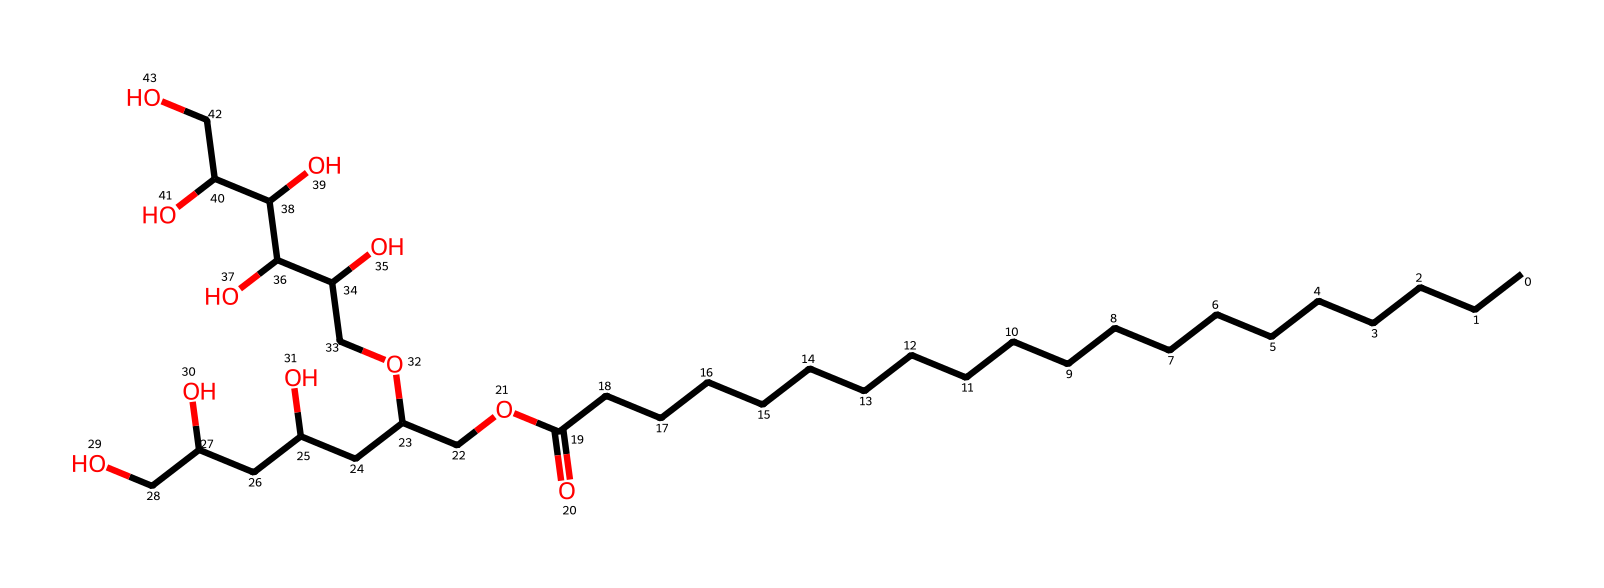What is the common name of this chemical? The SMILES string corresponds to Polysorbate 20, commonly known as Tween 20, which is a non-ionic surfactant.
Answer: Tween 20 How many carbon atoms are present in this molecule? By counting the 'C' characters in the SMILES representation, there are 20 carbon atoms in total.
Answer: 20 What type of functional group is indicated by "OCC" in this structure? The "OCC" part indicates an ether or ester functional group due to the presence of carbon (C) chains flanked by oxygen (O).
Answer: ether Is this molecule hydrophilic or hydrophobic? The presence of multiple hydroxyl (OH) groups indicates that it is hydrophilic, as these groups attract water molecules.
Answer: hydrophilic How many hydroxyl groups are present in the molecular structure? By identifying "O" that is immediately followed by hydrogen or carbon atoms, there are a total of 6 hydroxyl groups in the structure.
Answer: 6 What role does Polysorbate 20 serve in food products like barbecue sauces? Polysorbate 20 acts as an emulsifier, helping to maintain a stable mixture of oil and water, preventing separation.
Answer: emulsifier Which part of the molecule contributes most to its surfactant properties? The long hydrophobic carbon chain contributes most to its surfactant properties, allowing it to interact with oily substances.
Answer: carbon chain 